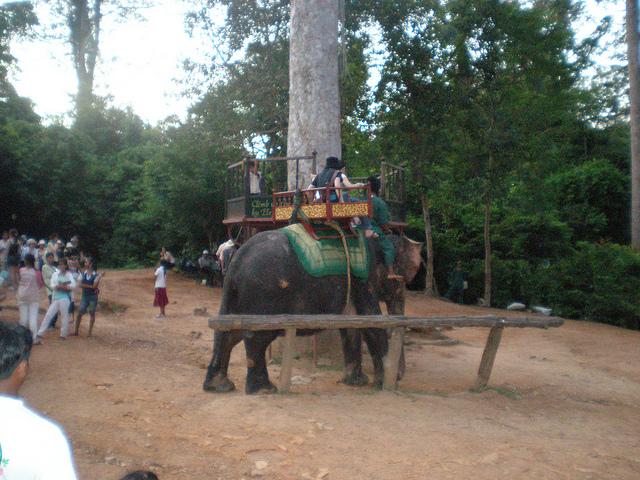What is the animal walking around?
Short answer required. Elephant. Is this a family?
Be succinct. No. Where are the kids?
Quick response, please. On elephant. How the seat anchored from the rear?
Be succinct. Rope. What country is this?
Answer briefly. India. Is there a car in the picture?
Concise answer only. No. Does this look like a ride?
Short answer required. Yes. What do all the animals have on their backs?
Keep it brief. Seats. Does the canopy top give off shade?
Quick response, please. No. What is the animal's work?
Be succinct. Carry people. 